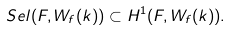<formula> <loc_0><loc_0><loc_500><loc_500>S e l ( F , W _ { f } ( k ) ) \subset H ^ { 1 } ( F , W _ { f } ( k ) ) .</formula> 